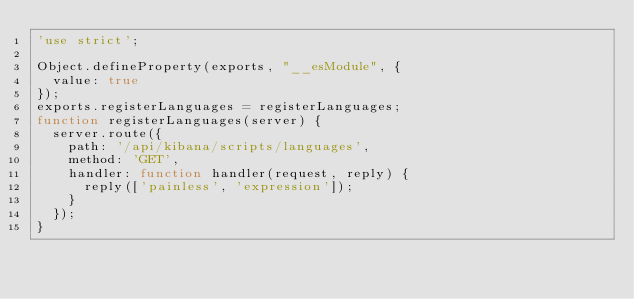<code> <loc_0><loc_0><loc_500><loc_500><_JavaScript_>'use strict';

Object.defineProperty(exports, "__esModule", {
  value: true
});
exports.registerLanguages = registerLanguages;
function registerLanguages(server) {
  server.route({
    path: '/api/kibana/scripts/languages',
    method: 'GET',
    handler: function handler(request, reply) {
      reply(['painless', 'expression']);
    }
  });
}
</code> 